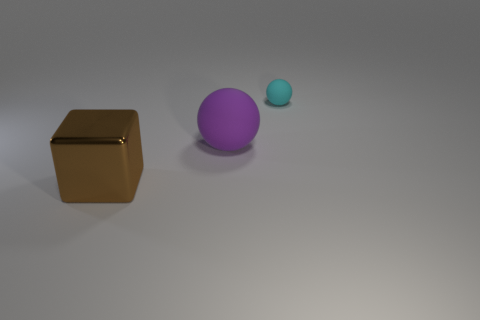Subtract all balls. How many objects are left? 1 Subtract 1 balls. How many balls are left? 1 Subtract all gray cylinders. How many green cubes are left? 0 Subtract all blue things. Subtract all tiny things. How many objects are left? 2 Add 3 brown metal objects. How many brown metal objects are left? 4 Add 3 purple balls. How many purple balls exist? 4 Add 3 tiny yellow rubber blocks. How many objects exist? 6 Subtract 0 yellow cylinders. How many objects are left? 3 Subtract all green spheres. Subtract all cyan blocks. How many spheres are left? 2 